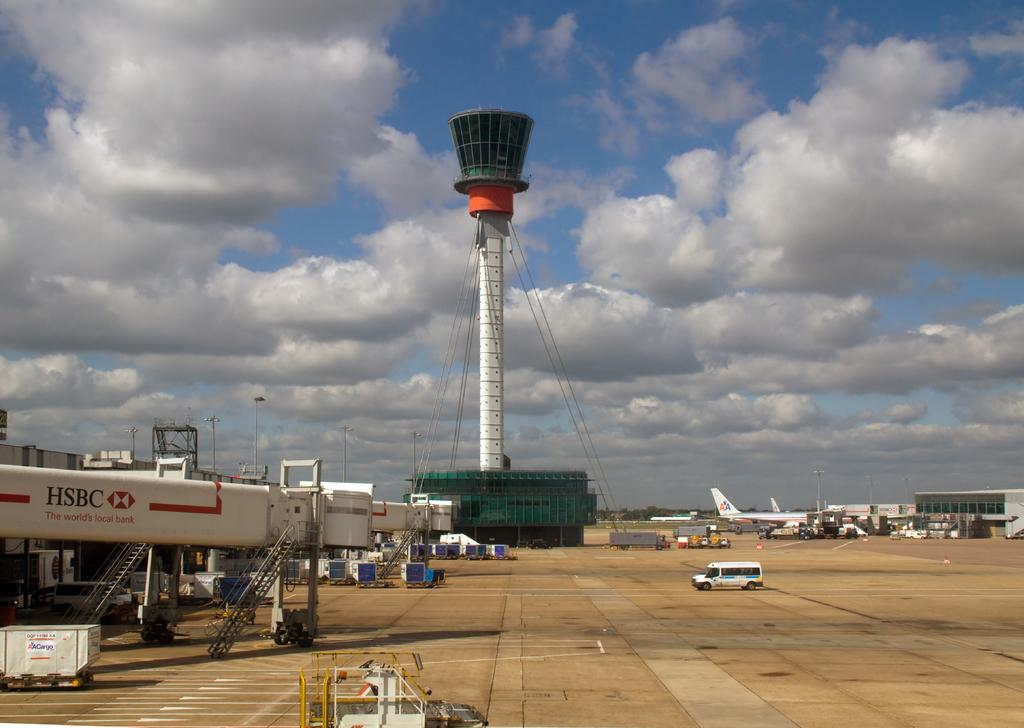<image>
Give a short and clear explanation of the subsequent image. An airport with a giant tower and an HSBC loading ramp. 